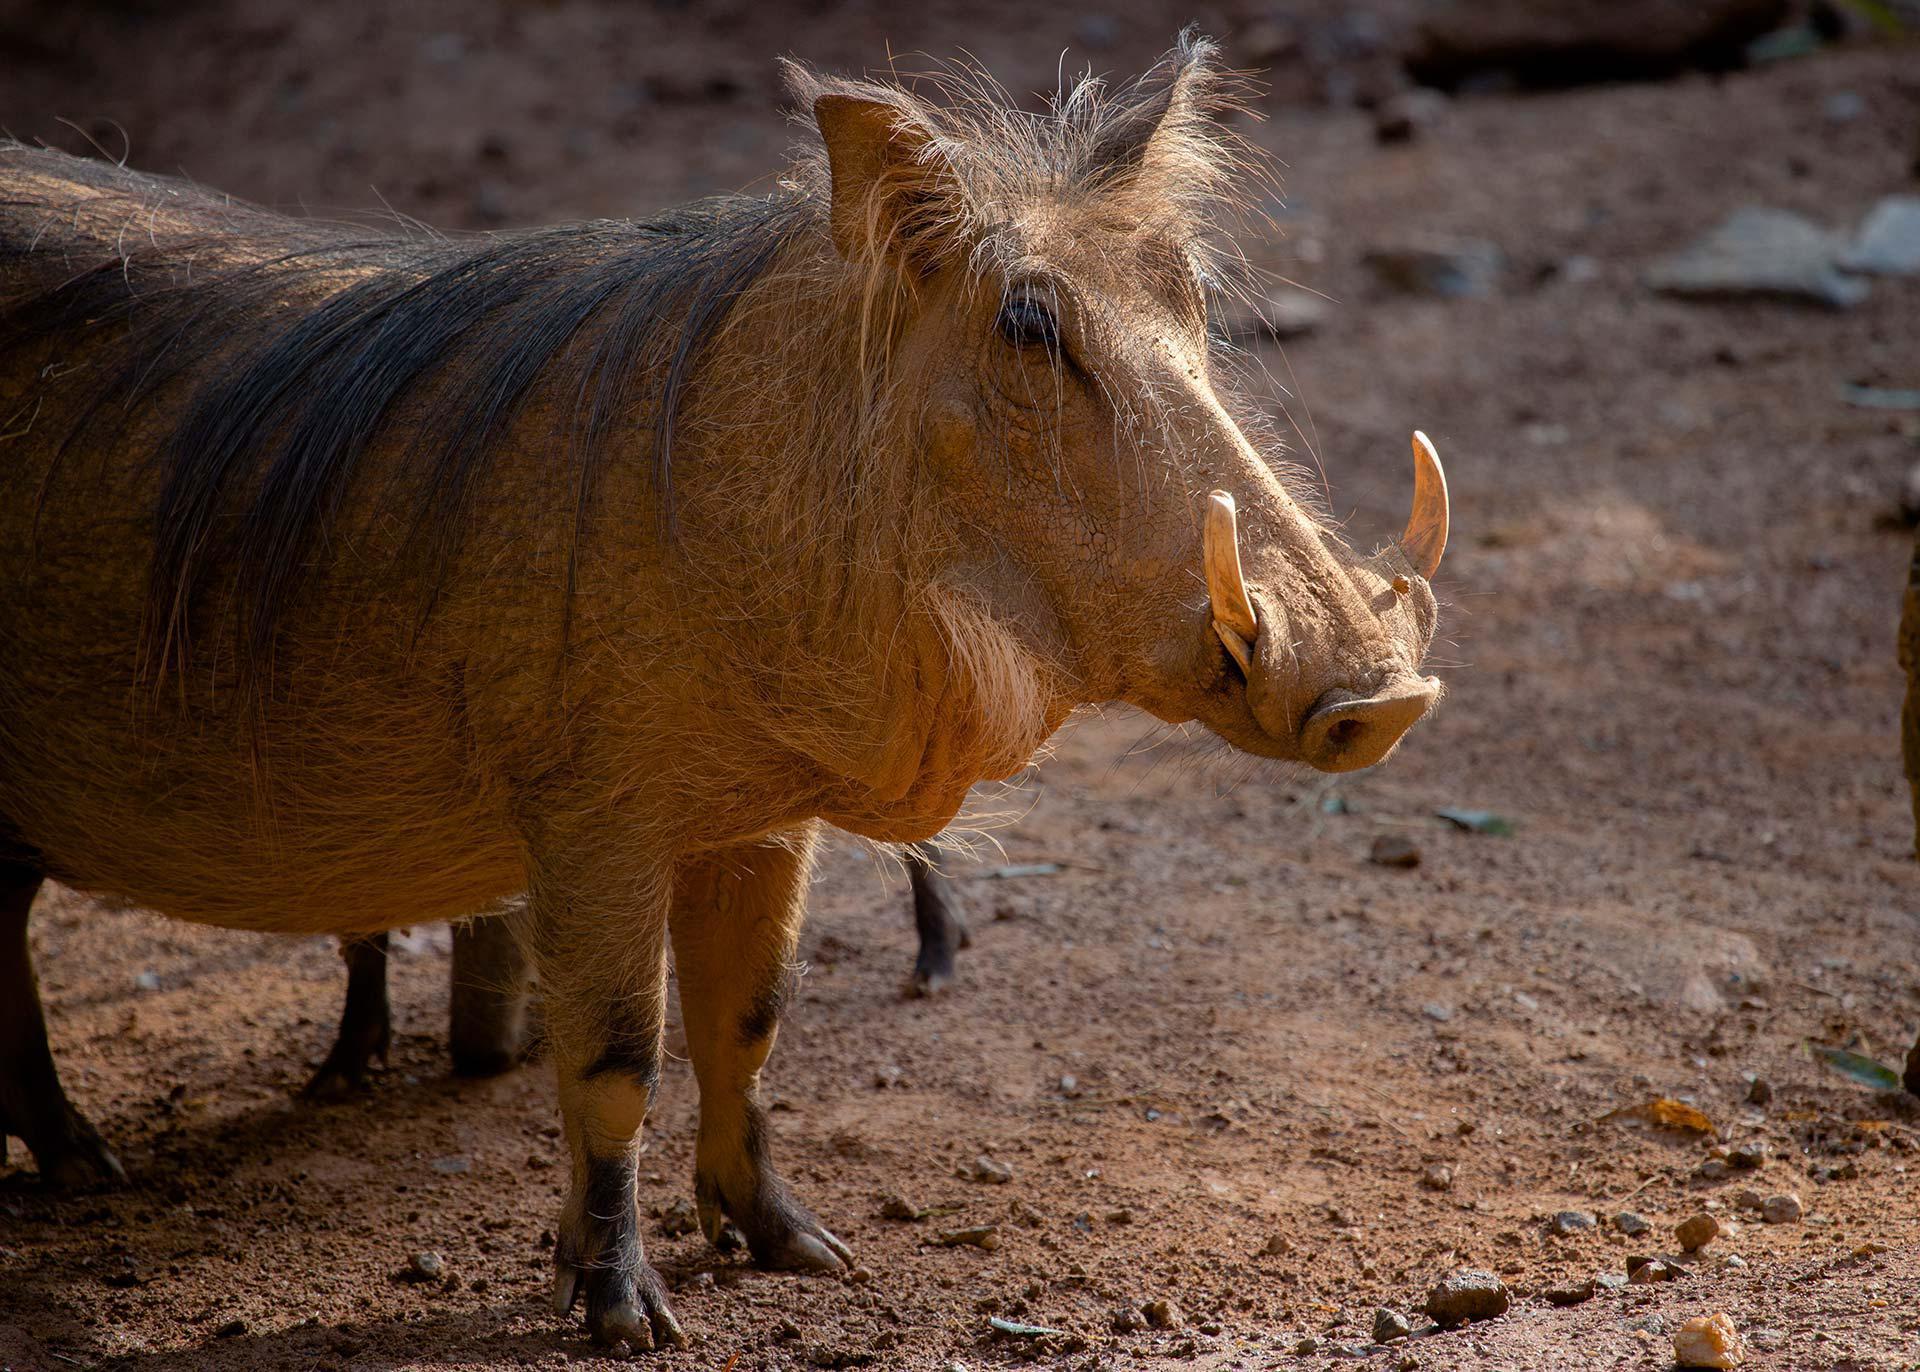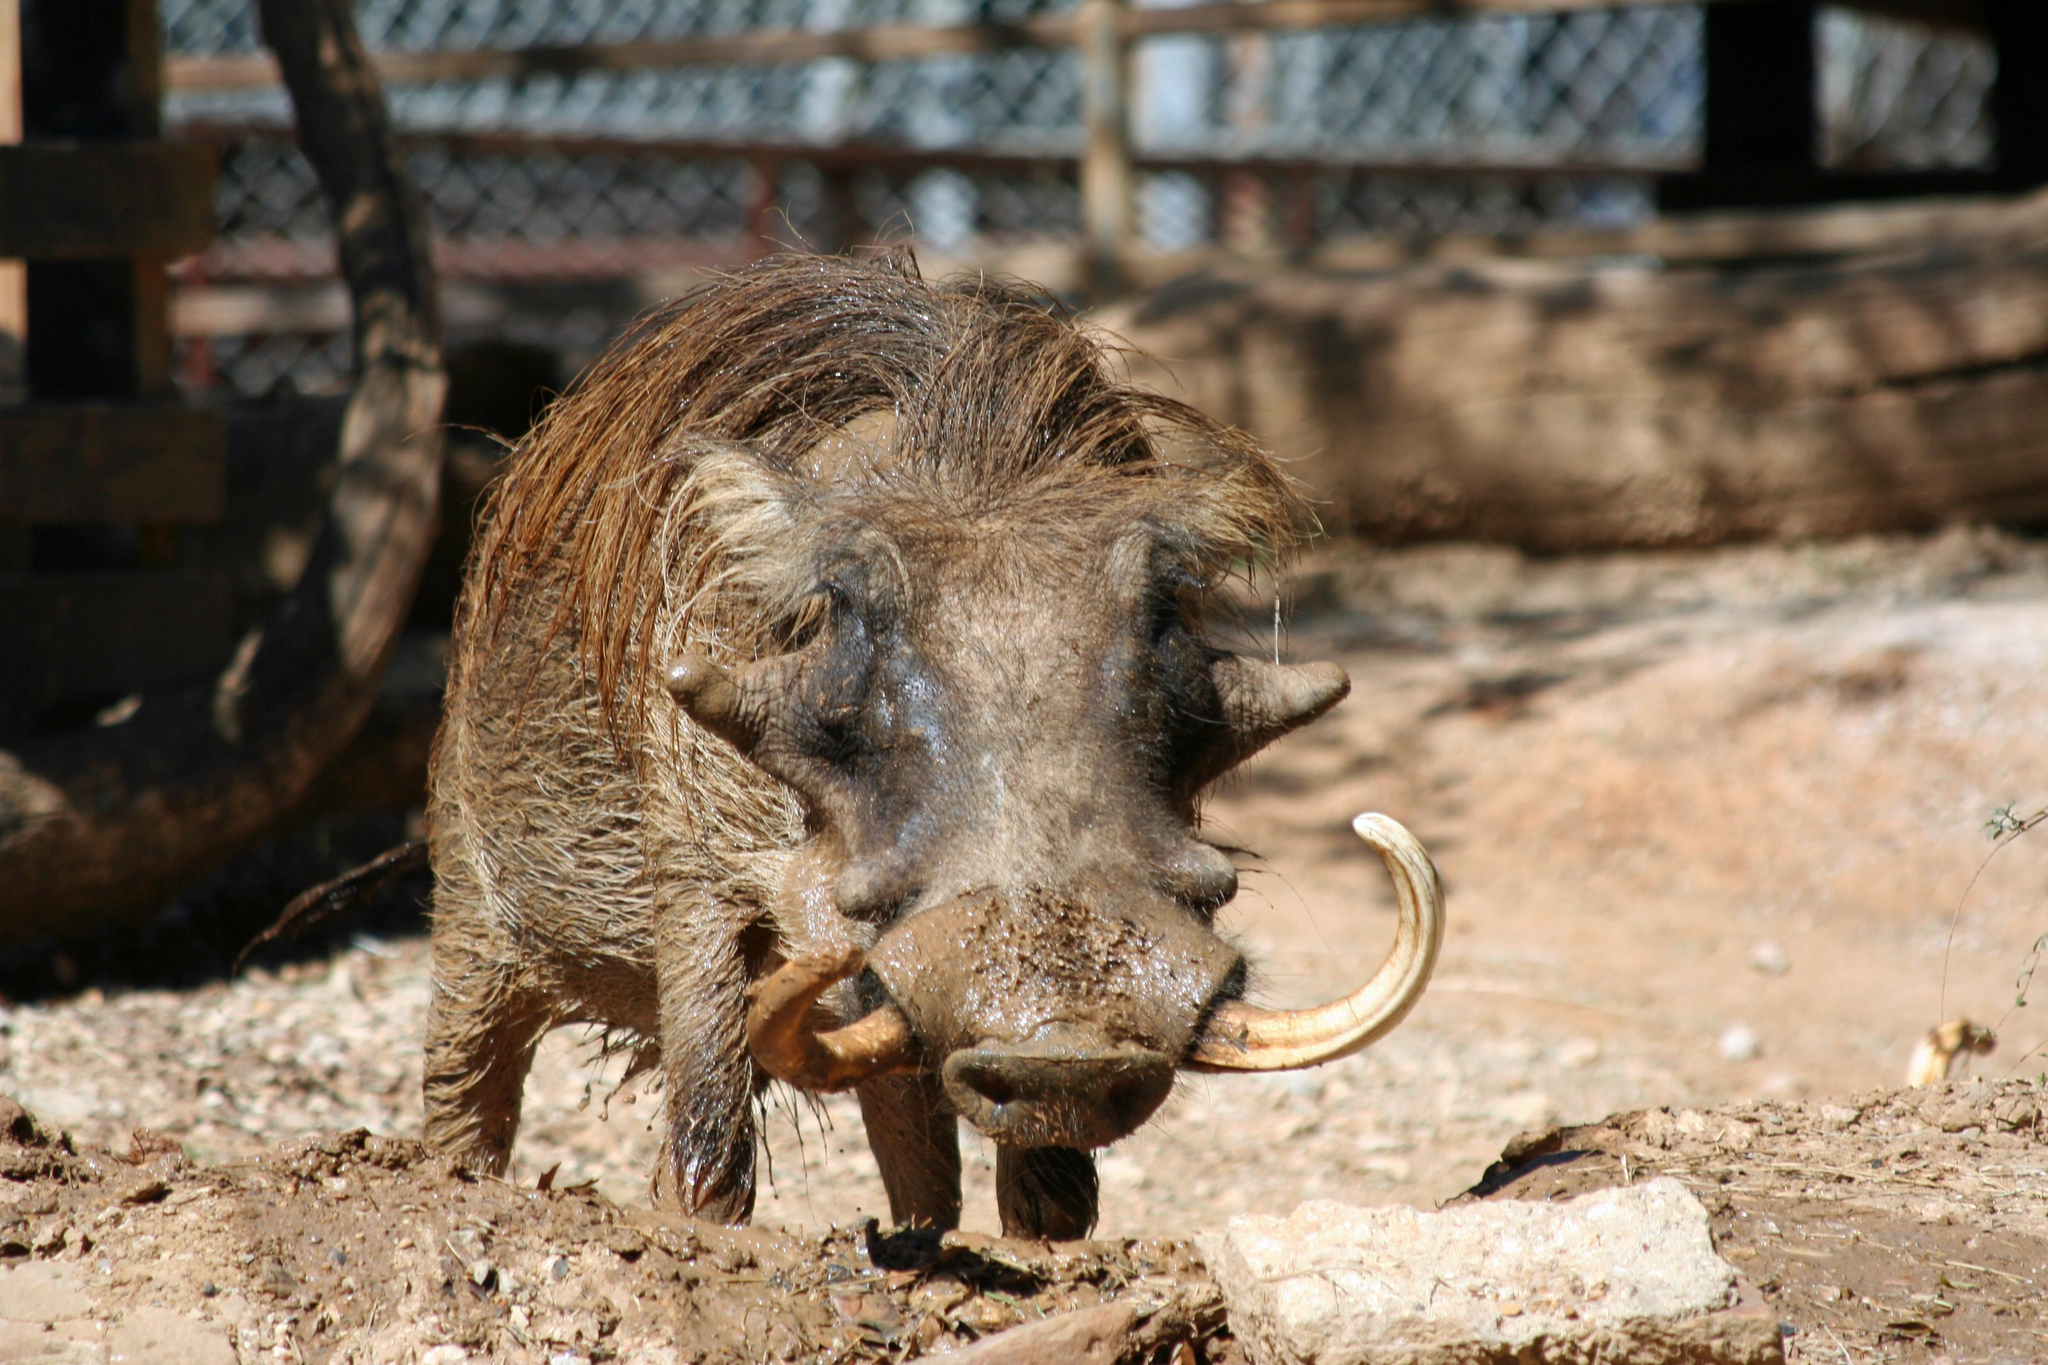The first image is the image on the left, the second image is the image on the right. For the images shown, is this caption "A boar is near the pig in one of the images." true? Answer yes or no. No. The first image is the image on the left, the second image is the image on the right. Examine the images to the left and right. Is the description "One image includes at least one bird with a standing warthog." accurate? Answer yes or no. No. 